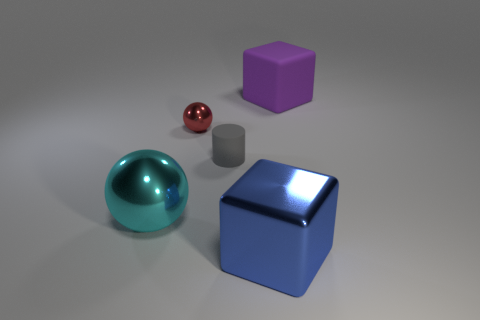Add 3 tiny yellow blocks. How many objects exist? 8 Subtract all blocks. How many objects are left? 3 Subtract all tiny red shiny objects. Subtract all tiny gray cylinders. How many objects are left? 3 Add 3 small red spheres. How many small red spheres are left? 4 Add 1 purple blocks. How many purple blocks exist? 2 Subtract 0 cyan cylinders. How many objects are left? 5 